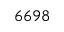<formula> <loc_0><loc_0><loc_500><loc_500>6 6 9 8</formula> 